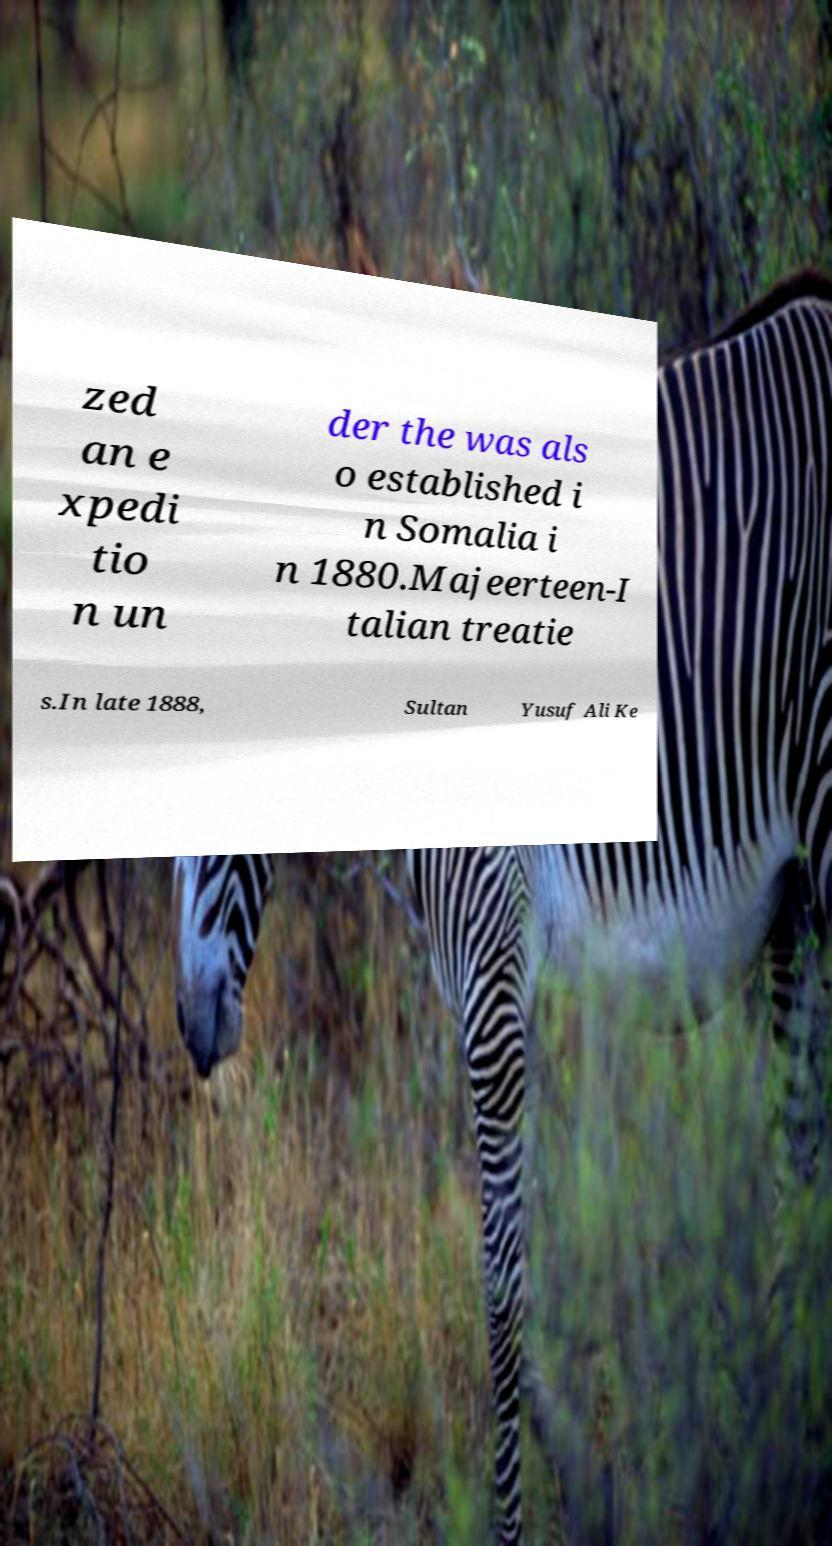There's text embedded in this image that I need extracted. Can you transcribe it verbatim? zed an e xpedi tio n un der the was als o established i n Somalia i n 1880.Majeerteen-I talian treatie s.In late 1888, Sultan Yusuf Ali Ke 